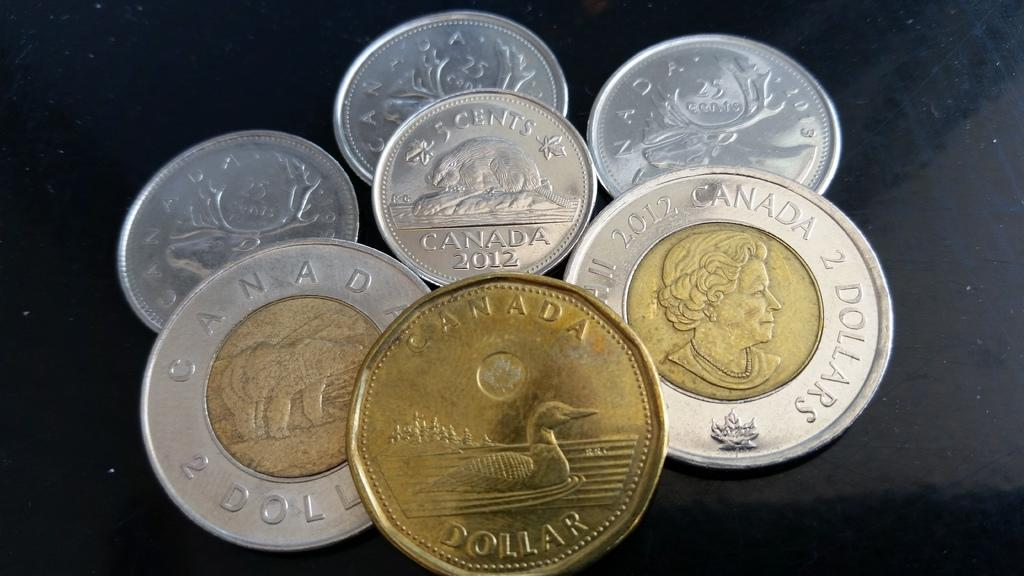<image>
Create a compact narrative representing the image presented. Seven coins including a Canadian one dollar coin. 